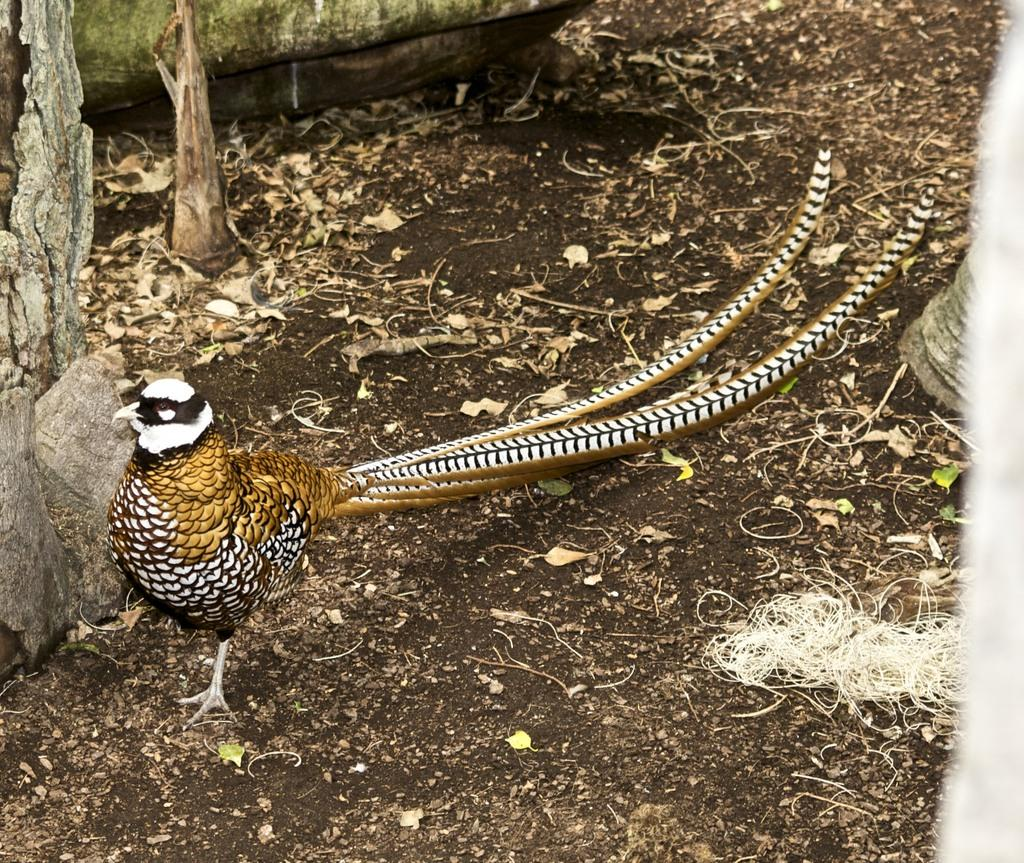What type of animal can be seen in the image? There is a bird in the image. Where is the bird located? The bird is on the land. What else can be seen in the image besides the bird? There are books visible in the image. What type of island is the bird resting on in the image? There is no island present in the image; the bird is on the land. What color is the yoke that the bird is wearing in the image? There is no yoke present in the image, and the bird is not wearing any clothing. 